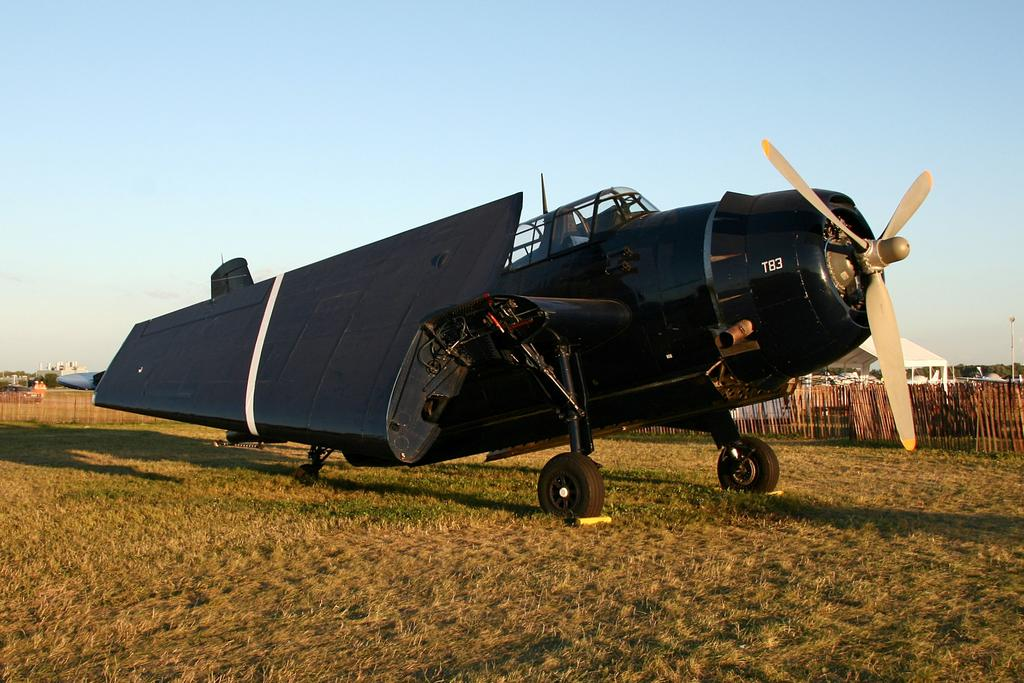Provide a one-sentence caption for the provided image. A black T83 plane on a field with its wings folded in. 